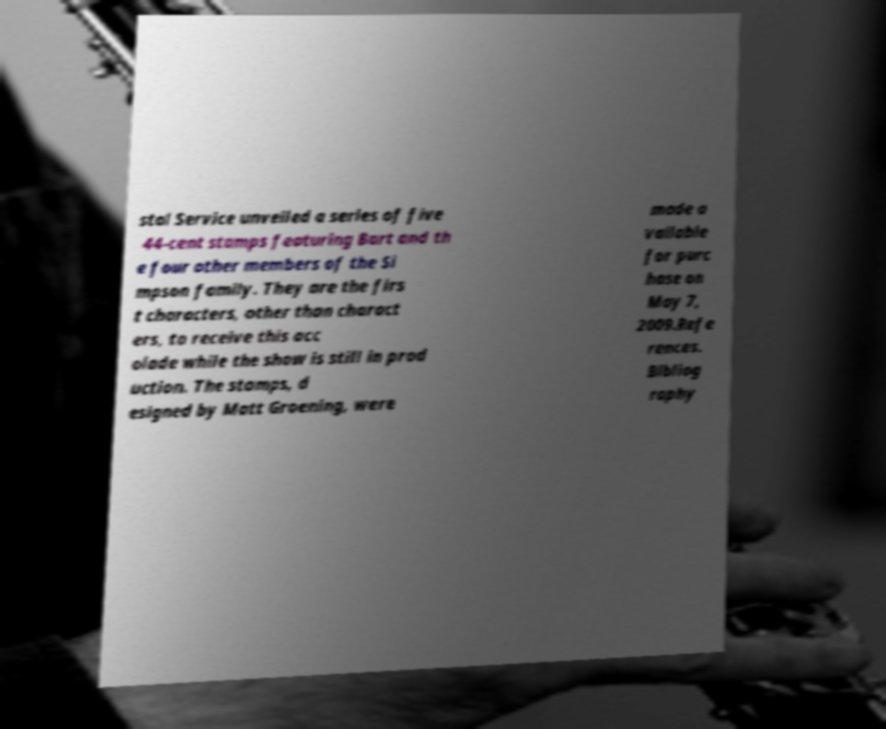I need the written content from this picture converted into text. Can you do that? stal Service unveiled a series of five 44-cent stamps featuring Bart and th e four other members of the Si mpson family. They are the firs t characters, other than charact ers, to receive this acc olade while the show is still in prod uction. The stamps, d esigned by Matt Groening, were made a vailable for purc hase on May 7, 2009.Refe rences. Bibliog raphy 